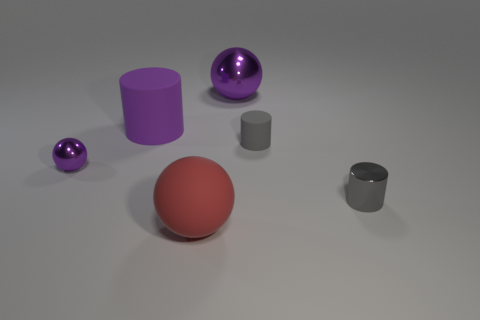How many brown cylinders are made of the same material as the big purple sphere?
Keep it short and to the point. 0. What number of objects are big purple cubes or small purple metal spheres?
Your answer should be compact. 1. Are there any rubber things on the right side of the shiny thing to the right of the big purple shiny ball?
Your answer should be compact. No. Are there more tiny gray rubber things that are right of the tiny matte object than large metal things that are on the right side of the tiny gray metal cylinder?
Your answer should be compact. No. What material is the large cylinder that is the same color as the small metal sphere?
Provide a succinct answer. Rubber. How many small things are the same color as the tiny rubber cylinder?
Provide a short and direct response. 1. Do the big matte cylinder that is on the right side of the small purple thing and the ball that is right of the red matte object have the same color?
Keep it short and to the point. Yes. Are there any tiny gray metallic things behind the purple cylinder?
Your answer should be very brief. No. What material is the large purple cylinder?
Offer a very short reply. Rubber. There is a purple thing to the left of the purple rubber cylinder; what shape is it?
Make the answer very short. Sphere. 